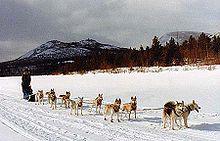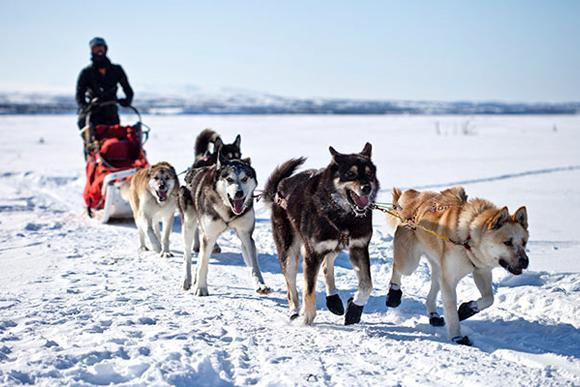The first image is the image on the left, the second image is the image on the right. For the images displayed, is the sentence "The dogs are heading toward the left in the image on the right." factually correct? Answer yes or no. No. The first image is the image on the left, the second image is the image on the right. Given the left and right images, does the statement "Both images show sled dog teams headed rightward and downward." hold true? Answer yes or no. Yes. 